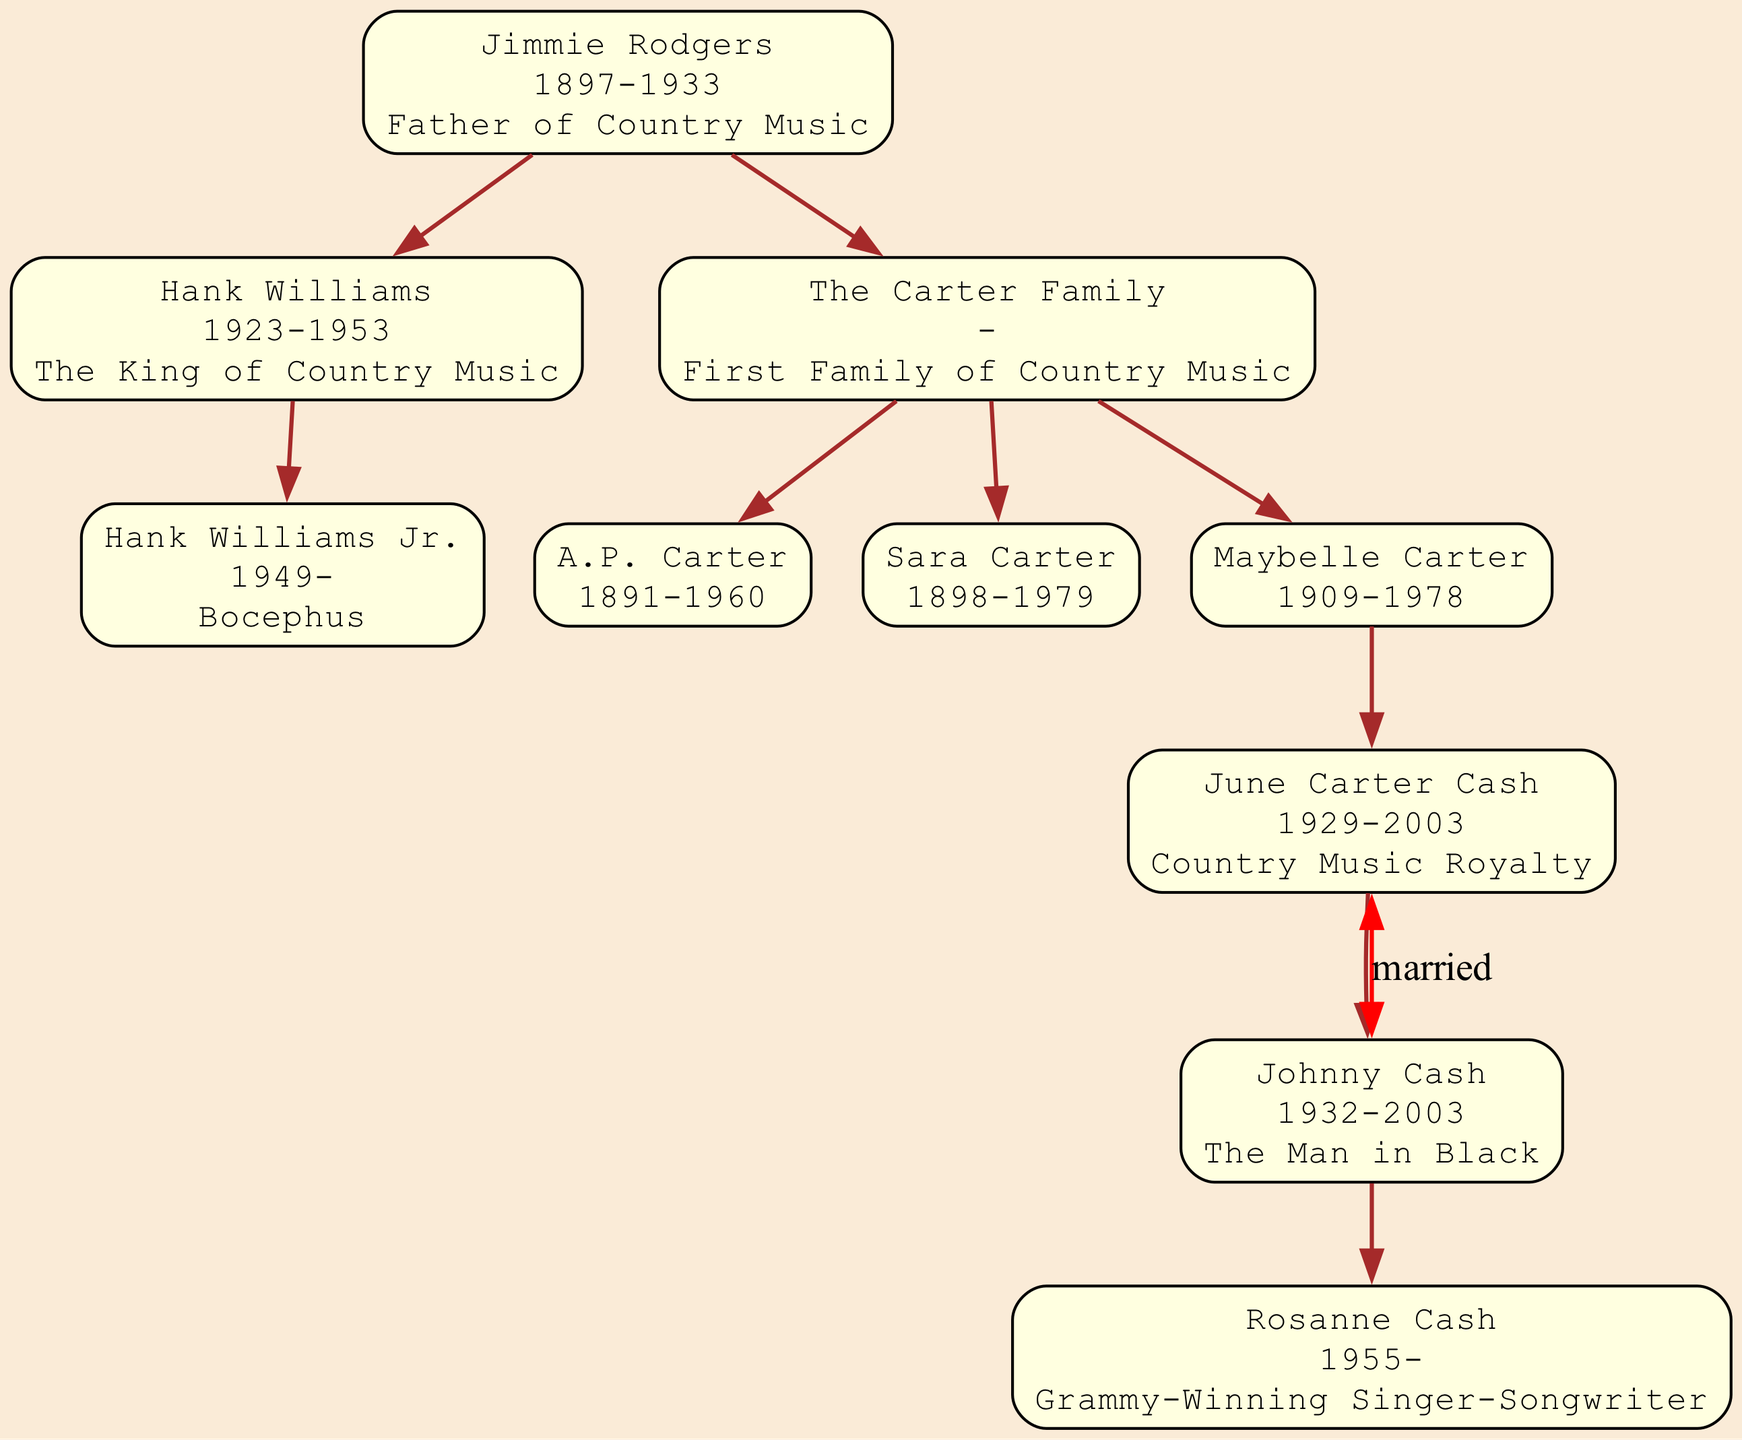What is the title of Jimmie Rodgers? The title of Jimmie Rodgers is the "Father of Country Music," as stated in his node on the family tree.
Answer: Father of Country Music Who are the members of The Carter Family? The members listed under The Carter Family include A.P. Carter, Sara Carter, and Maybelle Carter, each indicated in their respective sections in the diagram.
Answer: A.P. Carter, Sara Carter, Maybelle Carter How many descendants does Hank Williams have? Hank Williams has one direct descendant listed in the diagram, which is Hank Williams Jr., as shown under Hank Williams' node.
Answer: 1 Who is June Carter Cash married to? June Carter Cash is married to Johnny Cash, which is indicated in her node that lists her marriage alongside Johnny Cash's details.
Answer: Johnny Cash Which title is attributed to Hank Williams? Hank Williams is referred to as "The King of Country Music" in the family tree, as stated directly under his name in the corresponding node.
Answer: The King of Country Music What year was Hank Williams born? Hank Williams was born in 1923, which is specified in his node on the family tree diagram.
Answer: 1923 Who is the descendant of Johnny Cash? Rosanne Cash is the descendant of Johnny Cash, depicted as his daughter in the family tree under Johnny Cash's node.
Answer: Rosanne Cash What is the relationship between Jimmie Rodgers and Hank Williams? Jimmie Rodgers is Hank Williams' ancestor, which establishes a direct lineage from Jimmie Rodgers to Hank Williams as indicated by their positions in the tree.
Answer: Ancestor How many generations are represented in the family tree? The family tree shows three generations: Jimmie Rodgers as the first generation, Hank Williams and The Carter Family as the second generation, and Hank Williams Jr. and Rosanne Cash in the third generation.
Answer: 3 